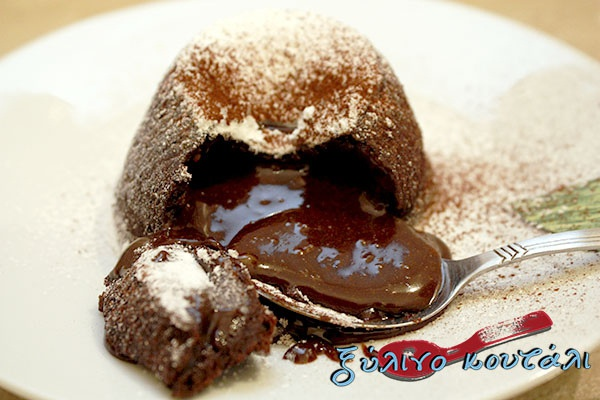Describe the objects in this image and their specific colors. I can see dining table in tan, ivory, brown, and darkgray tones, cake in tan, maroon, black, and beige tones, and spoon in tan, white, gray, and darkgray tones in this image. 